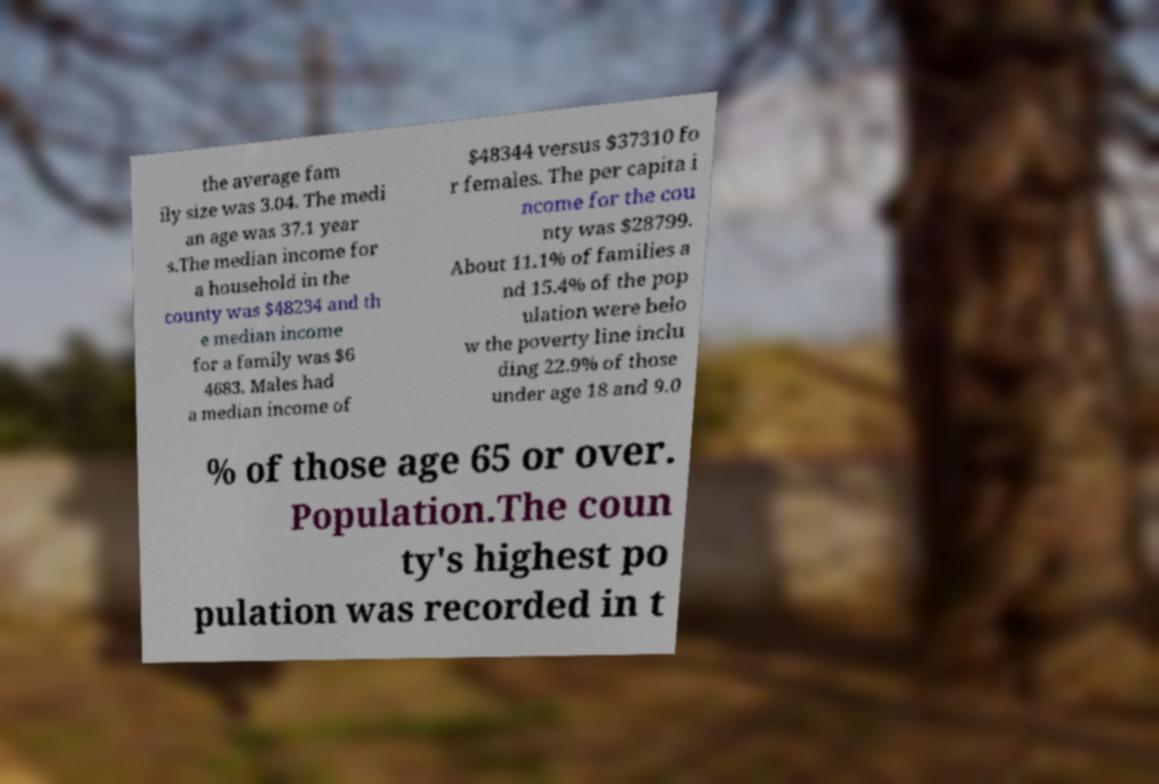Please identify and transcribe the text found in this image. the average fam ily size was 3.04. The medi an age was 37.1 year s.The median income for a household in the county was $48234 and th e median income for a family was $6 4683. Males had a median income of $48344 versus $37310 fo r females. The per capita i ncome for the cou nty was $28799. About 11.1% of families a nd 15.4% of the pop ulation were belo w the poverty line inclu ding 22.9% of those under age 18 and 9.0 % of those age 65 or over. Population.The coun ty's highest po pulation was recorded in t 